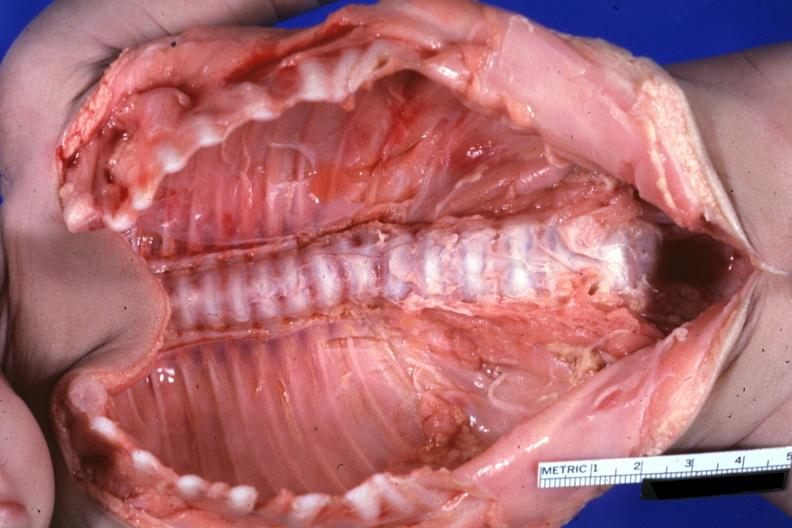what do natural color lesion at t12 see?
Answer the question using a single word or phrase. Protocol 